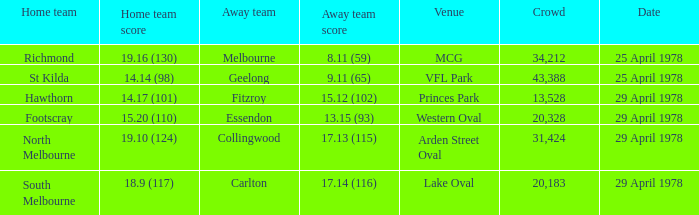Who was the home team at MCG? Richmond. 